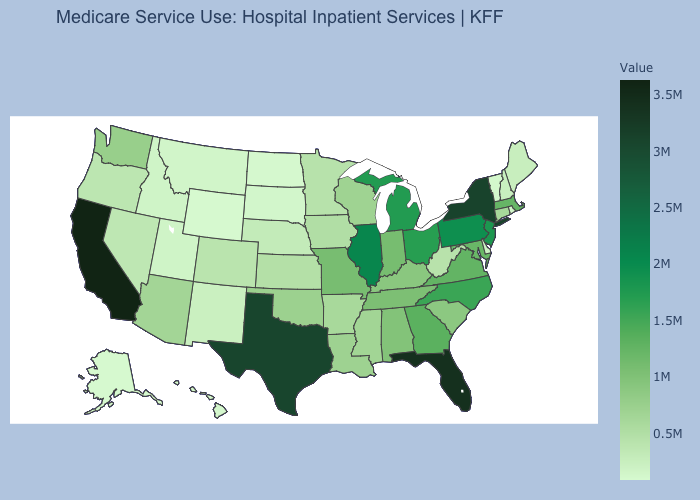Among the states that border Rhode Island , does Massachusetts have the highest value?
Short answer required. Yes. Among the states that border Maryland , does Delaware have the lowest value?
Keep it brief. Yes. Does Utah have the highest value in the USA?
Short answer required. No. Among the states that border Louisiana , does Texas have the highest value?
Write a very short answer. Yes. Among the states that border West Virginia , which have the highest value?
Quick response, please. Pennsylvania. Among the states that border Washington , does Idaho have the highest value?
Concise answer only. No. Does New York have the highest value in the Northeast?
Be succinct. Yes. Among the states that border Oklahoma , which have the lowest value?
Be succinct. New Mexico. 